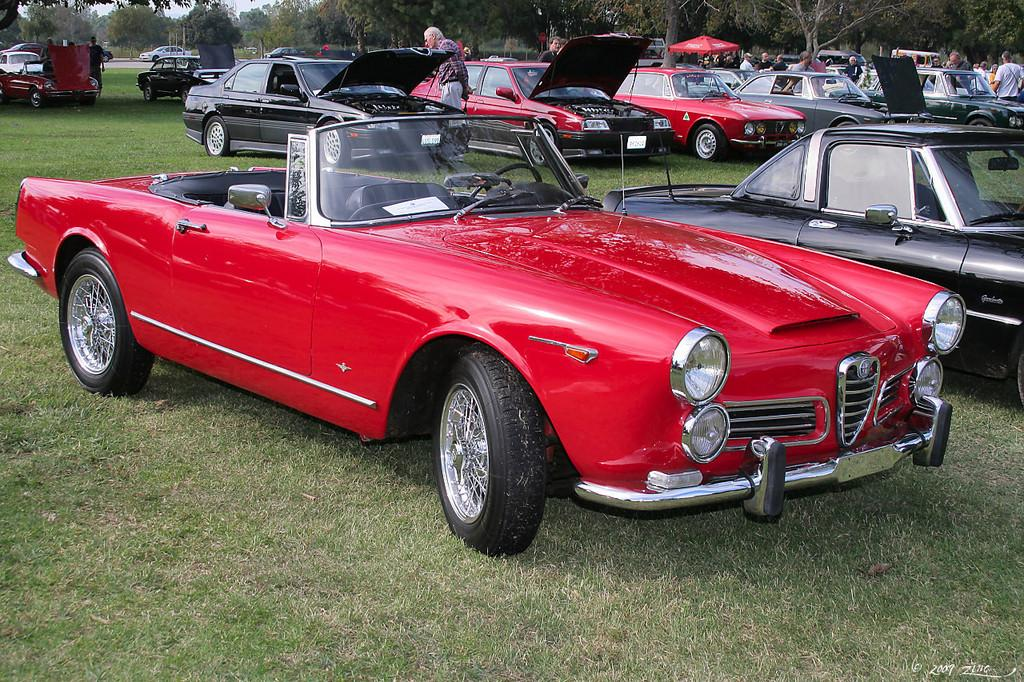What types of objects are present in the image? There are vehicles in the image. Can you describe the people in the image? There is a group of people in the image. What natural elements can be seen in the image? There are trees and grass in the image. What part of the natural environment is visible in the image? The sky is visible in the image. What actor is performing in the image? There is no actor present in the image; it features vehicles, a group of people, trees, grass, and the sky. Can you tell me how many copies of the same vehicle are in the image? There is no mention of multiple copies of the same vehicle in the image; only one vehicle is mentioned. 